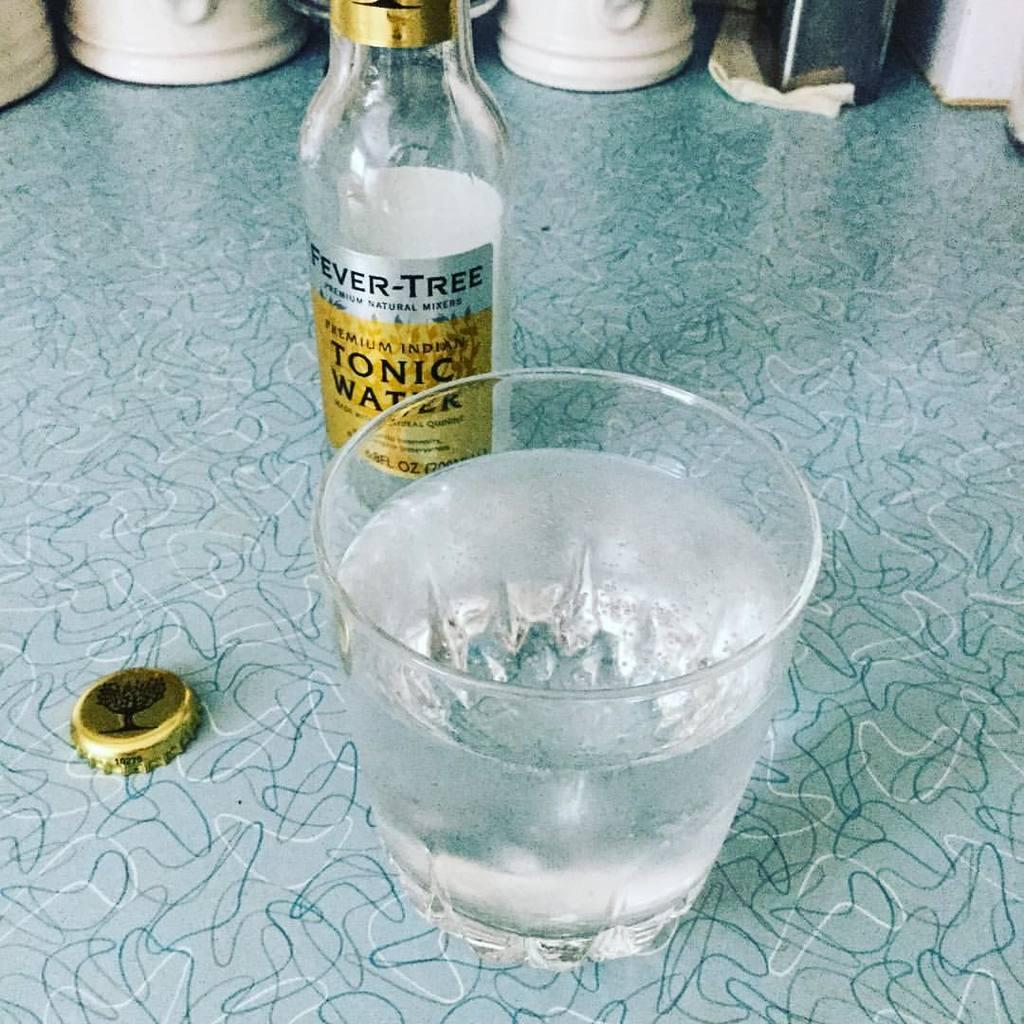Provide a one-sentence caption for the provided image. A bottle of tonic water behind a glass of water. 